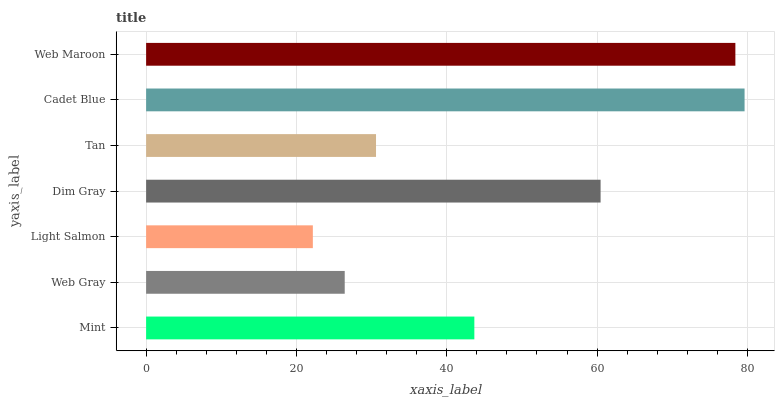Is Light Salmon the minimum?
Answer yes or no. Yes. Is Cadet Blue the maximum?
Answer yes or no. Yes. Is Web Gray the minimum?
Answer yes or no. No. Is Web Gray the maximum?
Answer yes or no. No. Is Mint greater than Web Gray?
Answer yes or no. Yes. Is Web Gray less than Mint?
Answer yes or no. Yes. Is Web Gray greater than Mint?
Answer yes or no. No. Is Mint less than Web Gray?
Answer yes or no. No. Is Mint the high median?
Answer yes or no. Yes. Is Mint the low median?
Answer yes or no. Yes. Is Tan the high median?
Answer yes or no. No. Is Cadet Blue the low median?
Answer yes or no. No. 